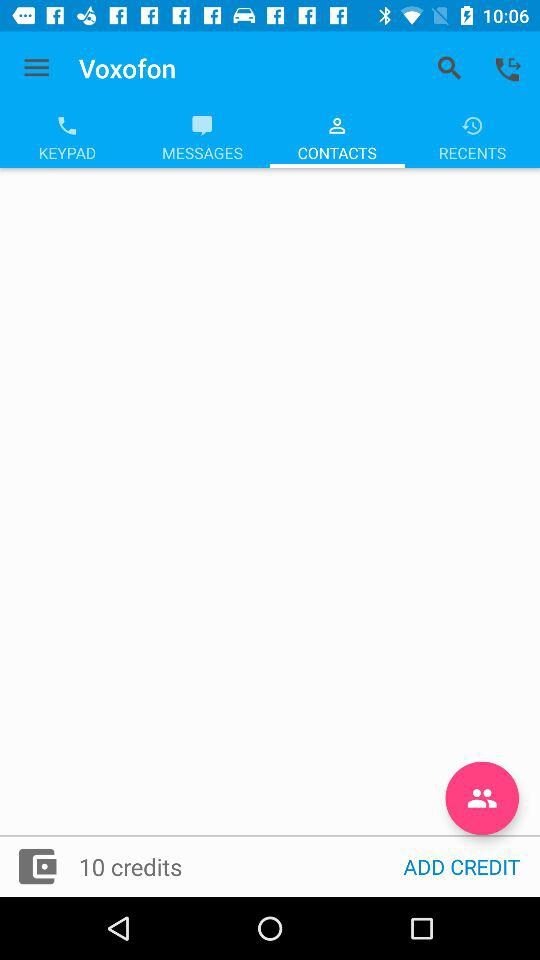How many more credits do I need to add to reach 20?
Answer the question using a single word or phrase. 10 